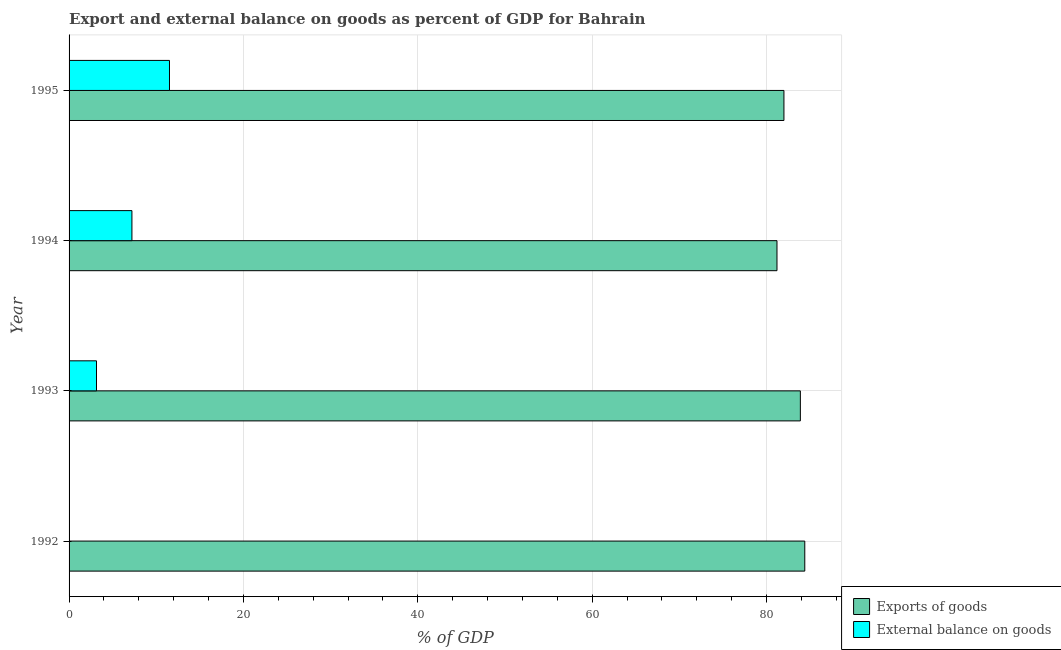How many different coloured bars are there?
Provide a succinct answer. 2. Are the number of bars per tick equal to the number of legend labels?
Give a very brief answer. No. Are the number of bars on each tick of the Y-axis equal?
Offer a very short reply. No. How many bars are there on the 3rd tick from the top?
Provide a succinct answer. 2. How many bars are there on the 1st tick from the bottom?
Offer a terse response. 1. What is the export of goods as percentage of gdp in 1992?
Ensure brevity in your answer.  84.38. Across all years, what is the maximum export of goods as percentage of gdp?
Make the answer very short. 84.38. Across all years, what is the minimum export of goods as percentage of gdp?
Provide a succinct answer. 81.19. What is the total export of goods as percentage of gdp in the graph?
Offer a very short reply. 331.44. What is the difference between the external balance on goods as percentage of gdp in 1993 and that in 1994?
Provide a succinct answer. -4.06. What is the difference between the external balance on goods as percentage of gdp in 1992 and the export of goods as percentage of gdp in 1994?
Your answer should be compact. -81.19. What is the average external balance on goods as percentage of gdp per year?
Keep it short and to the point. 5.47. In the year 1994, what is the difference between the external balance on goods as percentage of gdp and export of goods as percentage of gdp?
Make the answer very short. -73.98. In how many years, is the export of goods as percentage of gdp greater than 40 %?
Give a very brief answer. 4. What is the ratio of the export of goods as percentage of gdp in 1992 to that in 1993?
Offer a very short reply. 1.01. Is the difference between the export of goods as percentage of gdp in 1993 and 1995 greater than the difference between the external balance on goods as percentage of gdp in 1993 and 1995?
Offer a terse response. Yes. What is the difference between the highest and the second highest export of goods as percentage of gdp?
Your answer should be compact. 0.51. What is the difference between the highest and the lowest external balance on goods as percentage of gdp?
Your answer should be compact. 11.52. In how many years, is the external balance on goods as percentage of gdp greater than the average external balance on goods as percentage of gdp taken over all years?
Offer a terse response. 2. Is the sum of the export of goods as percentage of gdp in 1993 and 1995 greater than the maximum external balance on goods as percentage of gdp across all years?
Your answer should be compact. Yes. Are all the bars in the graph horizontal?
Offer a very short reply. Yes. Does the graph contain any zero values?
Keep it short and to the point. Yes. Does the graph contain grids?
Offer a very short reply. Yes. Where does the legend appear in the graph?
Your answer should be very brief. Bottom right. What is the title of the graph?
Your answer should be compact. Export and external balance on goods as percent of GDP for Bahrain. Does "Savings" appear as one of the legend labels in the graph?
Offer a very short reply. No. What is the label or title of the X-axis?
Offer a very short reply. % of GDP. What is the % of GDP of Exports of goods in 1992?
Offer a terse response. 84.38. What is the % of GDP of External balance on goods in 1992?
Your answer should be very brief. 0. What is the % of GDP of Exports of goods in 1993?
Ensure brevity in your answer.  83.87. What is the % of GDP of External balance on goods in 1993?
Offer a very short reply. 3.15. What is the % of GDP in Exports of goods in 1994?
Make the answer very short. 81.19. What is the % of GDP of External balance on goods in 1994?
Provide a succinct answer. 7.21. What is the % of GDP in Exports of goods in 1995?
Ensure brevity in your answer.  81.99. What is the % of GDP of External balance on goods in 1995?
Your answer should be very brief. 11.52. Across all years, what is the maximum % of GDP of Exports of goods?
Offer a very short reply. 84.38. Across all years, what is the maximum % of GDP of External balance on goods?
Your response must be concise. 11.52. Across all years, what is the minimum % of GDP in Exports of goods?
Give a very brief answer. 81.19. What is the total % of GDP of Exports of goods in the graph?
Offer a very short reply. 331.44. What is the total % of GDP of External balance on goods in the graph?
Offer a terse response. 21.87. What is the difference between the % of GDP in Exports of goods in 1992 and that in 1993?
Ensure brevity in your answer.  0.51. What is the difference between the % of GDP of Exports of goods in 1992 and that in 1994?
Your response must be concise. 3.19. What is the difference between the % of GDP in Exports of goods in 1992 and that in 1995?
Give a very brief answer. 2.39. What is the difference between the % of GDP of Exports of goods in 1993 and that in 1994?
Your answer should be compact. 2.68. What is the difference between the % of GDP of External balance on goods in 1993 and that in 1994?
Your answer should be compact. -4.06. What is the difference between the % of GDP in Exports of goods in 1993 and that in 1995?
Offer a very short reply. 1.88. What is the difference between the % of GDP in External balance on goods in 1993 and that in 1995?
Ensure brevity in your answer.  -8.37. What is the difference between the % of GDP in Exports of goods in 1994 and that in 1995?
Give a very brief answer. -0.8. What is the difference between the % of GDP in External balance on goods in 1994 and that in 1995?
Offer a terse response. -4.31. What is the difference between the % of GDP in Exports of goods in 1992 and the % of GDP in External balance on goods in 1993?
Ensure brevity in your answer.  81.24. What is the difference between the % of GDP of Exports of goods in 1992 and the % of GDP of External balance on goods in 1994?
Give a very brief answer. 77.17. What is the difference between the % of GDP of Exports of goods in 1992 and the % of GDP of External balance on goods in 1995?
Offer a very short reply. 72.87. What is the difference between the % of GDP of Exports of goods in 1993 and the % of GDP of External balance on goods in 1994?
Give a very brief answer. 76.67. What is the difference between the % of GDP in Exports of goods in 1993 and the % of GDP in External balance on goods in 1995?
Offer a very short reply. 72.36. What is the difference between the % of GDP in Exports of goods in 1994 and the % of GDP in External balance on goods in 1995?
Provide a short and direct response. 69.68. What is the average % of GDP of Exports of goods per year?
Your response must be concise. 82.86. What is the average % of GDP in External balance on goods per year?
Give a very brief answer. 5.47. In the year 1993, what is the difference between the % of GDP of Exports of goods and % of GDP of External balance on goods?
Offer a very short reply. 80.73. In the year 1994, what is the difference between the % of GDP in Exports of goods and % of GDP in External balance on goods?
Your answer should be compact. 73.98. In the year 1995, what is the difference between the % of GDP of Exports of goods and % of GDP of External balance on goods?
Your answer should be very brief. 70.47. What is the ratio of the % of GDP in Exports of goods in 1992 to that in 1994?
Offer a very short reply. 1.04. What is the ratio of the % of GDP in Exports of goods in 1992 to that in 1995?
Give a very brief answer. 1.03. What is the ratio of the % of GDP in Exports of goods in 1993 to that in 1994?
Offer a terse response. 1.03. What is the ratio of the % of GDP in External balance on goods in 1993 to that in 1994?
Offer a very short reply. 0.44. What is the ratio of the % of GDP in External balance on goods in 1993 to that in 1995?
Ensure brevity in your answer.  0.27. What is the ratio of the % of GDP of Exports of goods in 1994 to that in 1995?
Provide a succinct answer. 0.99. What is the ratio of the % of GDP of External balance on goods in 1994 to that in 1995?
Ensure brevity in your answer.  0.63. What is the difference between the highest and the second highest % of GDP in Exports of goods?
Offer a terse response. 0.51. What is the difference between the highest and the second highest % of GDP of External balance on goods?
Your answer should be compact. 4.31. What is the difference between the highest and the lowest % of GDP in Exports of goods?
Your answer should be compact. 3.19. What is the difference between the highest and the lowest % of GDP of External balance on goods?
Provide a succinct answer. 11.52. 